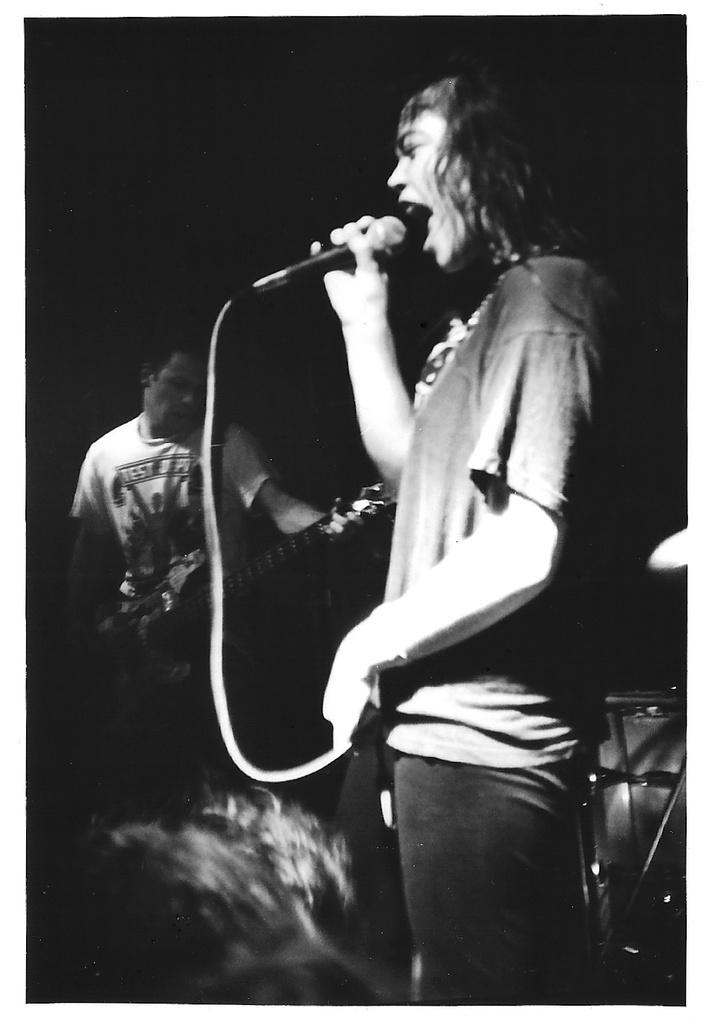How many people are in the image? There are two persons in the image. What is one person doing in the image? One person is playing a guitar. What is the other person doing in the image? The other person is singing into a microphone. What type of minister can be seen preaching to the giants in the image? There is no minister or giants present in the image; it features two people, one playing a guitar and the other singing into a microphone. 